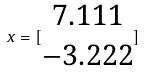Convert formula to latex. <formula><loc_0><loc_0><loc_500><loc_500>x = [ \begin{matrix} 7 . 1 1 1 \\ - 3 . 2 2 2 \end{matrix} ]</formula> 